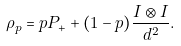Convert formula to latex. <formula><loc_0><loc_0><loc_500><loc_500>\rho _ { p } = p P _ { + } + ( 1 - p ) \frac { I \otimes I } { d ^ { 2 } } .</formula> 